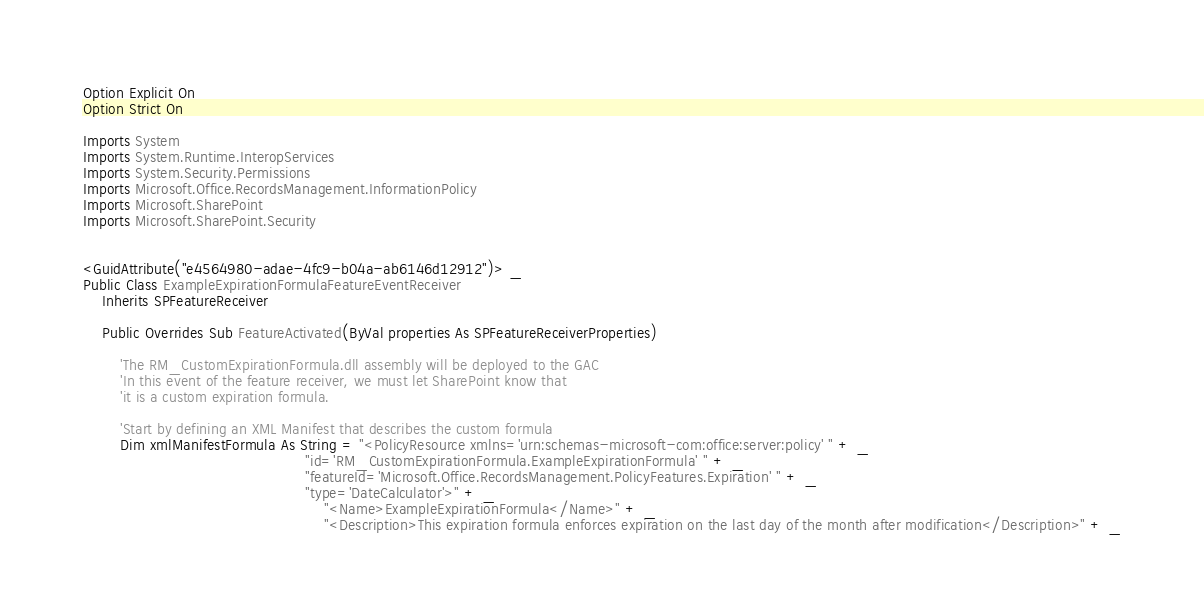<code> <loc_0><loc_0><loc_500><loc_500><_VisualBasic_>Option Explicit On
Option Strict On

Imports System
Imports System.Runtime.InteropServices
Imports System.Security.Permissions
Imports Microsoft.Office.RecordsManagement.InformationPolicy
Imports Microsoft.SharePoint
Imports Microsoft.SharePoint.Security


<GuidAttribute("e4564980-adae-4fc9-b04a-ab6146d12912")> _
Public Class ExampleExpirationFormulaFeatureEventReceiver 
    Inherits SPFeatureReceiver

    Public Overrides Sub FeatureActivated(ByVal properties As SPFeatureReceiverProperties)

        'The RM_CustomExpirationFormula.dll assembly will be deployed to the GAC
        'In this event of the feature receiver, we must let SharePoint know that
        'it is a custom expiration formula. 

        'Start by defining an XML Manifest that describes the custom formula
        Dim xmlManifestFormula As String = "<PolicyResource xmlns='urn:schemas-microsoft-com:office:server:policy' " + _
                                                "id='RM_CustomExpirationFormula.ExampleExpirationFormula' " + _
                                                "featureId='Microsoft.Office.RecordsManagement.PolicyFeatures.Expiration' " + _
                                                "type='DateCalculator'>" + _
                                                    "<Name>ExampleExpirationFormula</Name>" + _
                                                    "<Description>This expiration formula enforces expiration on the last day of the month after modification</Description>" + _</code> 